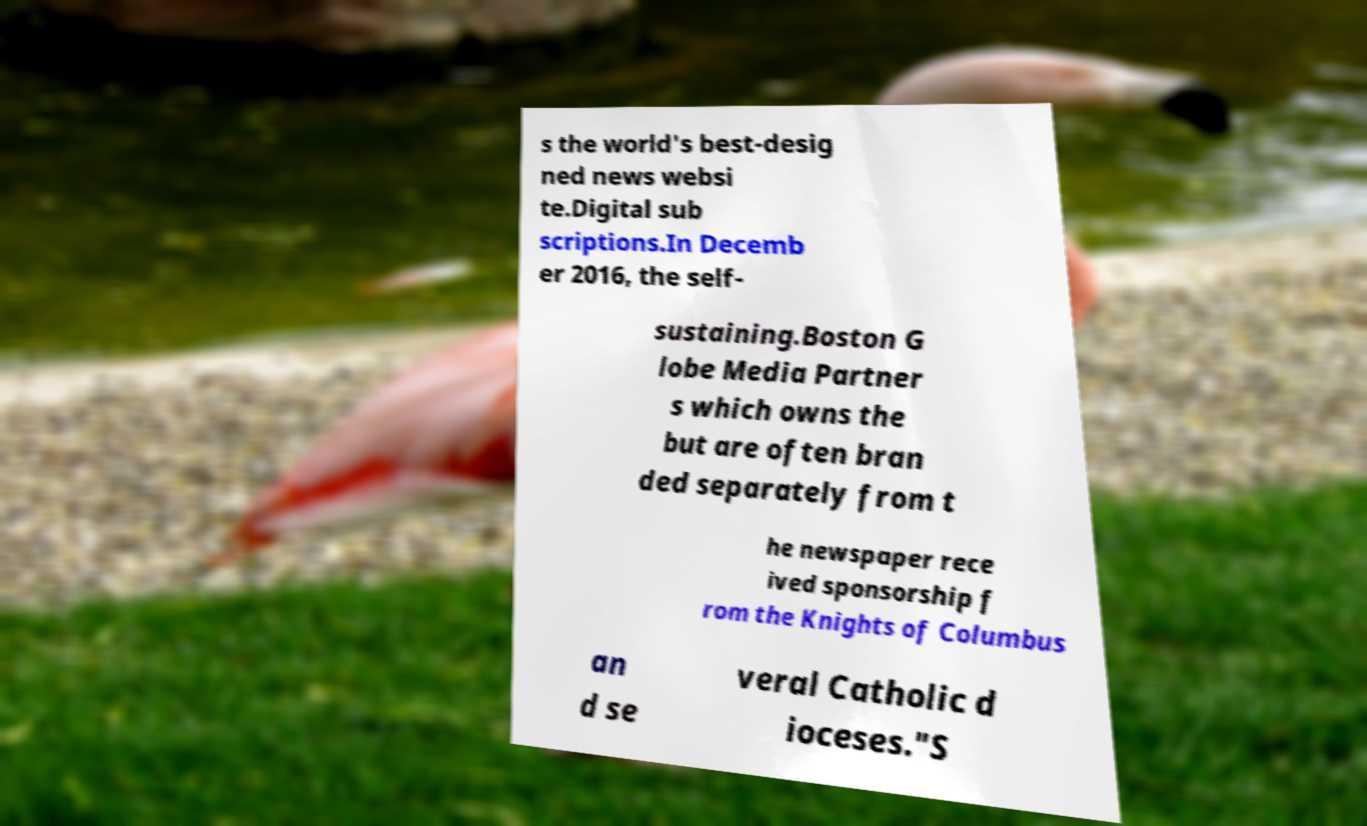Please read and relay the text visible in this image. What does it say? s the world's best-desig ned news websi te.Digital sub scriptions.In Decemb er 2016, the self- sustaining.Boston G lobe Media Partner s which owns the but are often bran ded separately from t he newspaper rece ived sponsorship f rom the Knights of Columbus an d se veral Catholic d ioceses."S 